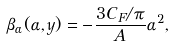Convert formula to latex. <formula><loc_0><loc_0><loc_500><loc_500>\beta _ { \alpha } ( \alpha , y ) = - \frac { 3 C _ { F } / \pi } { A } \alpha ^ { 2 } ,</formula> 